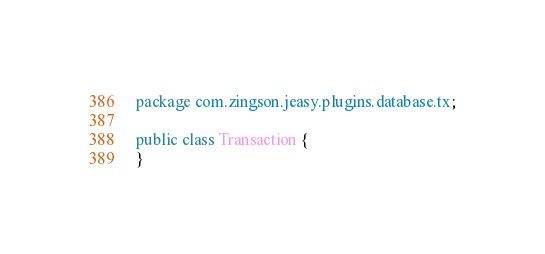<code> <loc_0><loc_0><loc_500><loc_500><_Java_>package com.zingson.jeasy.plugins.database.tx;

public class Transaction {
}
</code> 